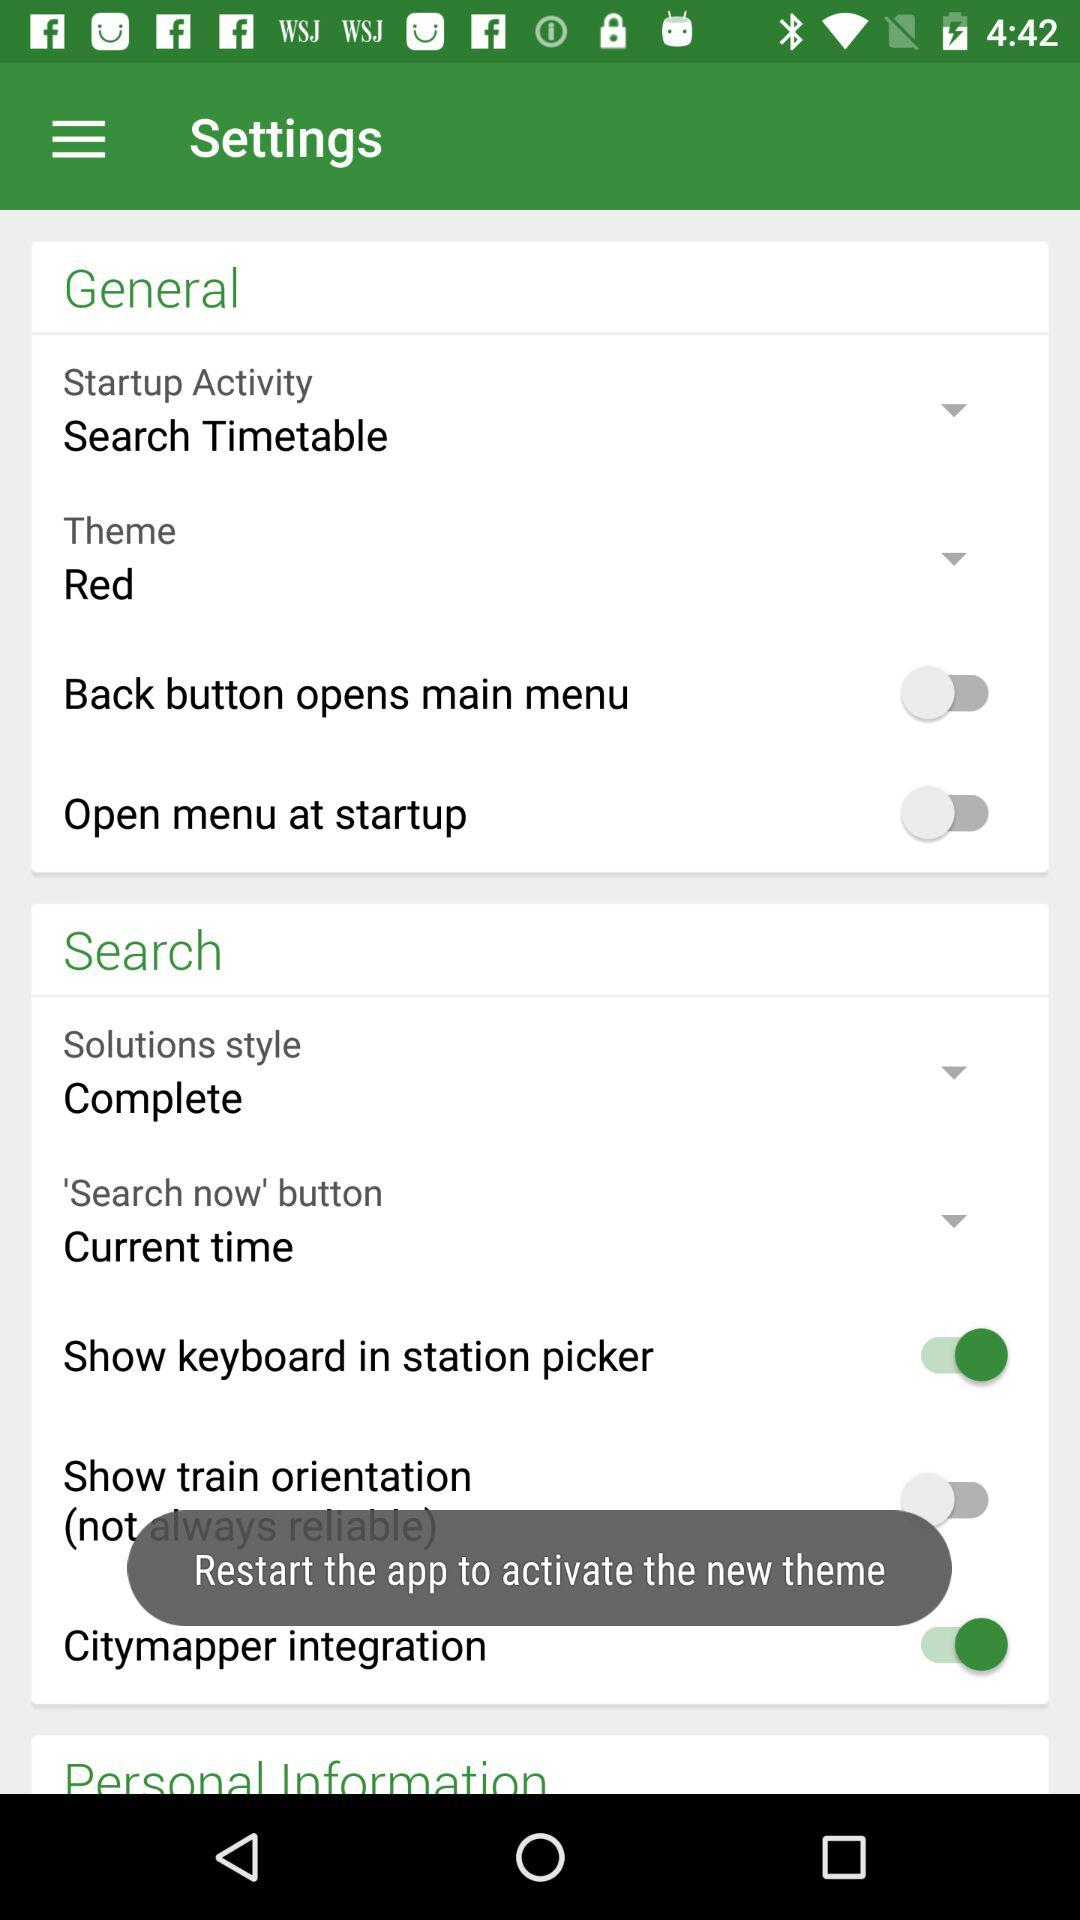What is the status of the "Citymapper integration" setting? The status of the "Citymapper integration" setting is "on". 